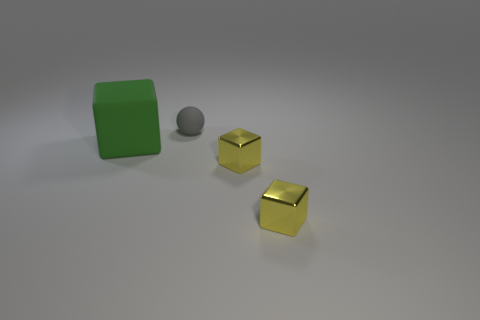Add 1 large blocks. How many objects exist? 5 Subtract all balls. How many objects are left? 3 Subtract 0 purple cubes. How many objects are left? 4 Subtract all cyan metallic cylinders. Subtract all rubber blocks. How many objects are left? 3 Add 2 matte blocks. How many matte blocks are left? 3 Add 2 small yellow things. How many small yellow things exist? 4 